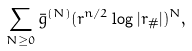Convert formula to latex. <formula><loc_0><loc_0><loc_500><loc_500>\sum _ { N \geq 0 } \bar { g } ^ { ( N ) } ( r ^ { n / 2 } \log | r _ { \# } | ) ^ { N } ,</formula> 